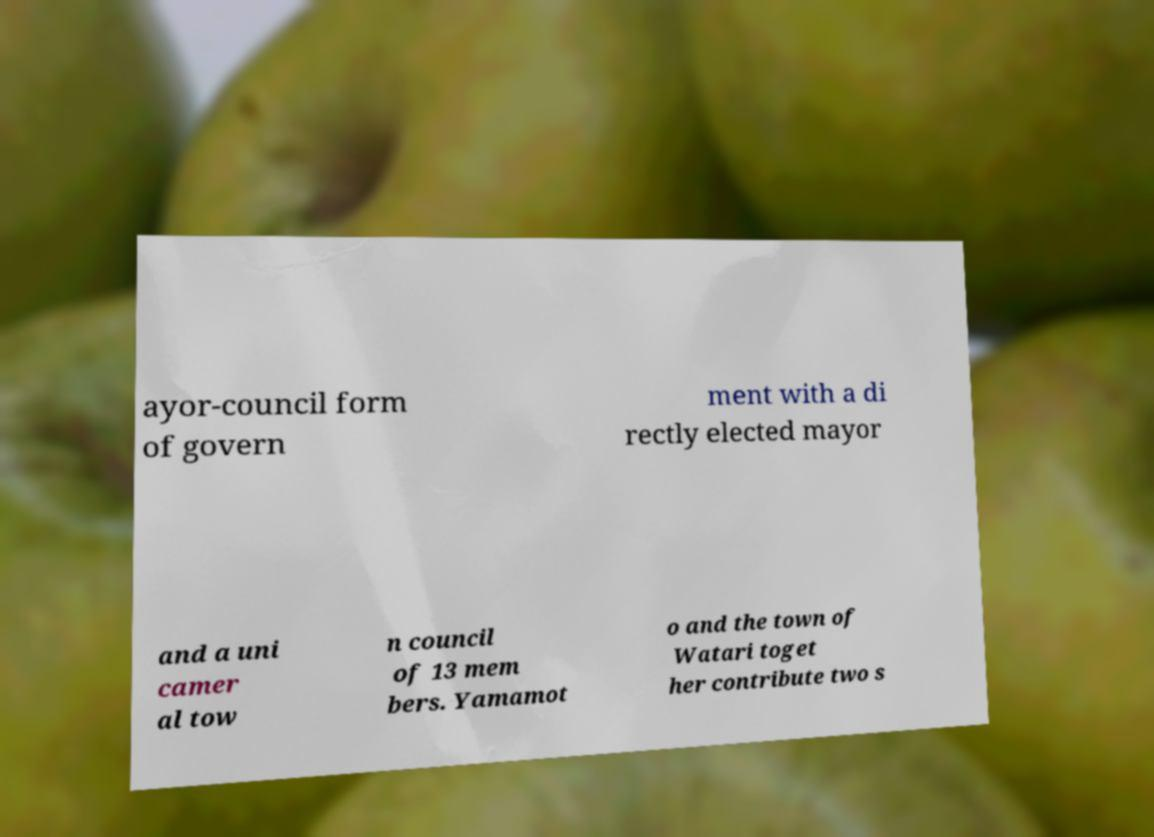Can you accurately transcribe the text from the provided image for me? ayor-council form of govern ment with a di rectly elected mayor and a uni camer al tow n council of 13 mem bers. Yamamot o and the town of Watari toget her contribute two s 